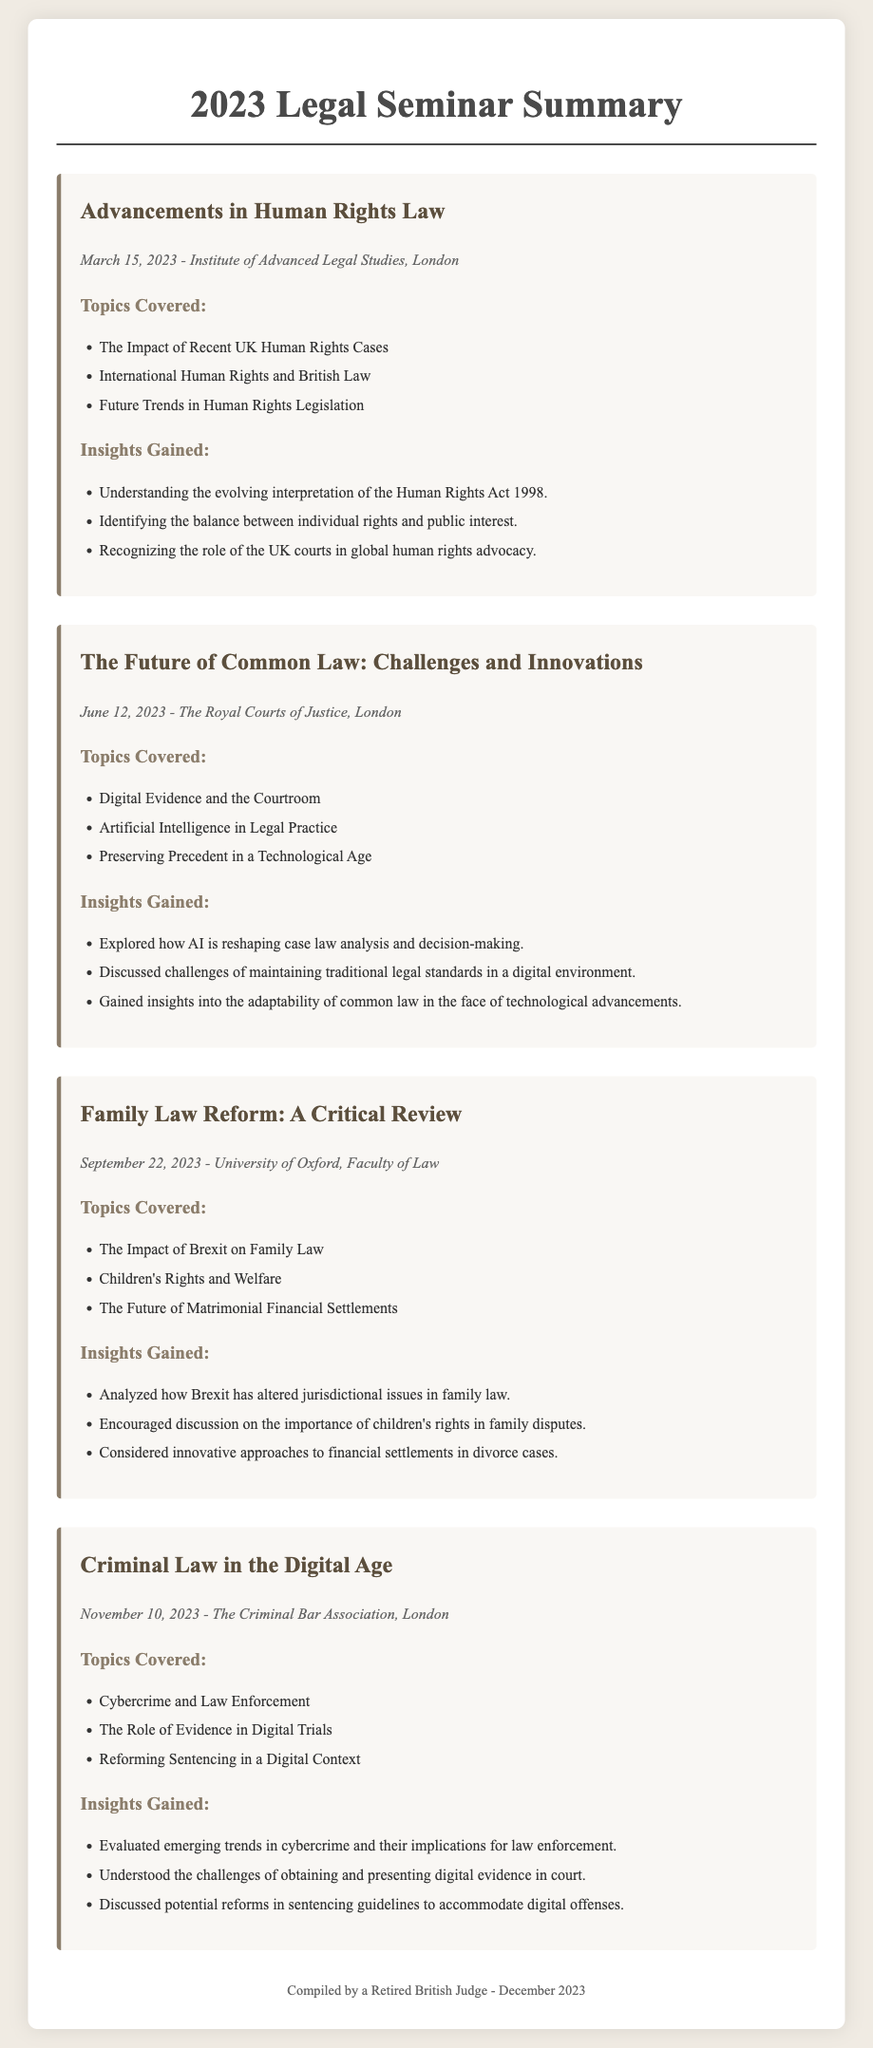What was the date of the seminar on Human Rights Law? The document provides the date of the seminar on Human Rights Law, which is March 15, 2023.
Answer: March 15, 2023 What is one topic covered in the seminar about Common Law? The document lists various topics covered, including "Digital Evidence and the Courtroom."
Answer: Digital Evidence and the Courtroom Where was the Family Law Reform seminar held? The venue of the Family Law Reform seminar is given as the University of Oxford, Faculty of Law.
Answer: University of Oxford, Faculty of Law What insight was gained regarding children's rights? Analyzed how the seminar addressed the importance of children's rights in family disputes, which is explicitly mentioned.
Answer: Importance of children's rights How many seminars were conducted in 2023? The document lists four distinct seminars that took place throughout the year.
Answer: Four What is a challenge discussed in the seminar on Criminal Law? The document highlights "Obtaining and presenting digital evidence in court" as a challenge during the Criminal Law seminar.
Answer: Obtaining and presenting digital evidence in court What was the last seminar held in 2023? The detail of the last seminar conducted in 2023 is specified, which was on Criminal Law in the Digital Age.
Answer: Criminal Law in the Digital Age Who compiled the seminar summary? The footer of the document states it was compiled by a retired British judge.
Answer: A retired British judge 